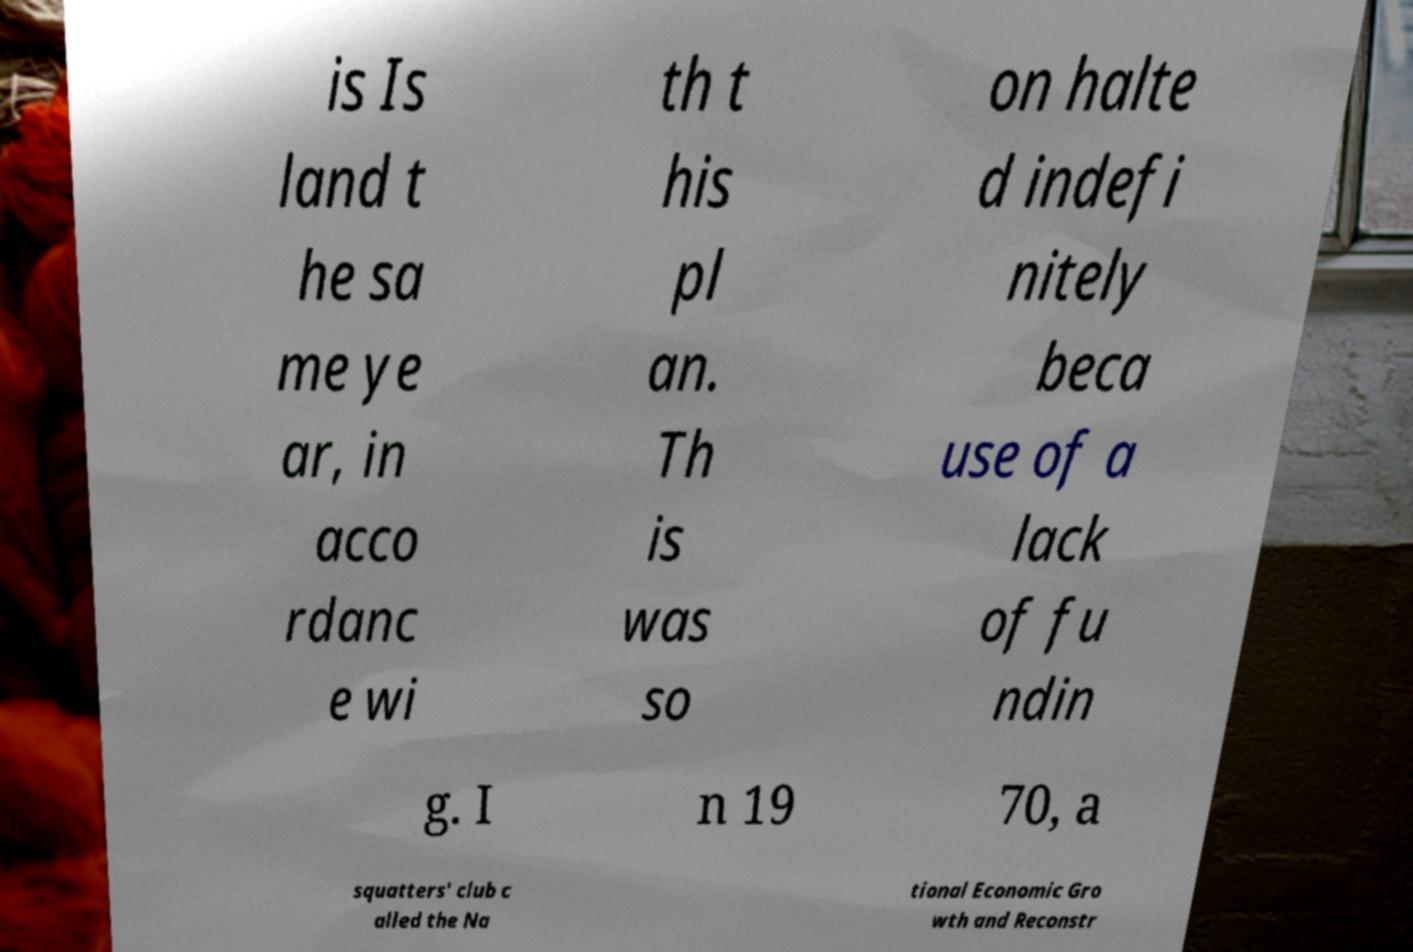Please read and relay the text visible in this image. What does it say? is Is land t he sa me ye ar, in acco rdanc e wi th t his pl an. Th is was so on halte d indefi nitely beca use of a lack of fu ndin g. I n 19 70, a squatters' club c alled the Na tional Economic Gro wth and Reconstr 